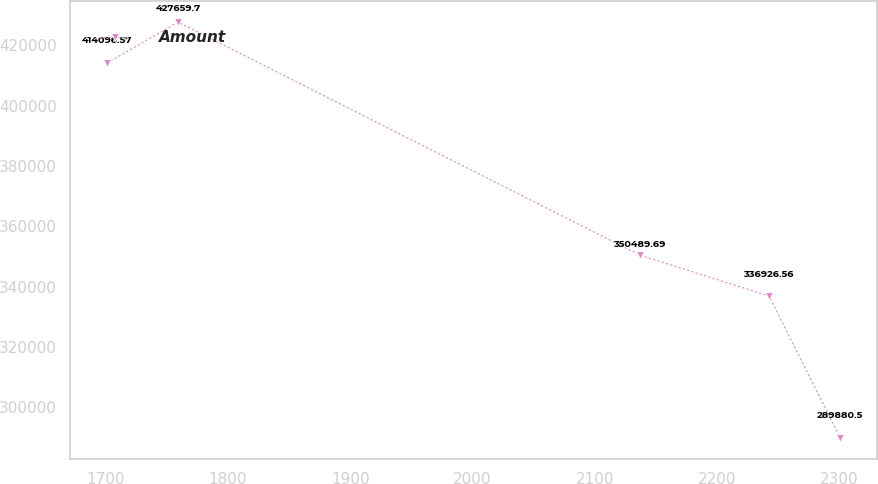Convert chart to OTSL. <chart><loc_0><loc_0><loc_500><loc_500><line_chart><ecel><fcel>Amount<nl><fcel>1701.16<fcel>414097<nl><fcel>1759.38<fcel>427660<nl><fcel>2136.64<fcel>350490<nl><fcel>2242.42<fcel>336927<nl><fcel>2300.64<fcel>289880<nl></chart> 